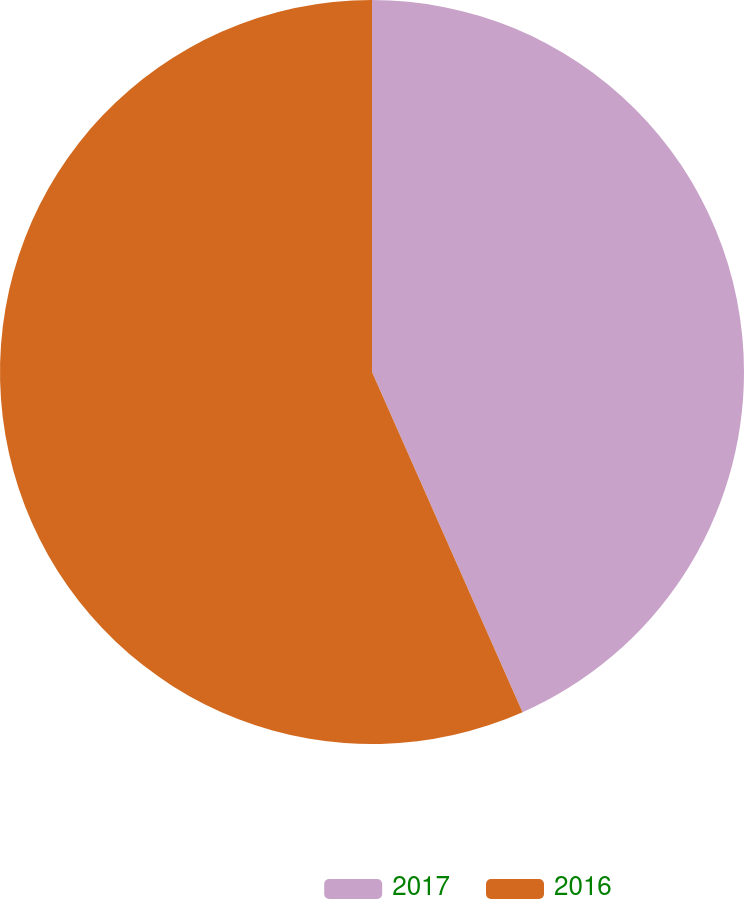Convert chart. <chart><loc_0><loc_0><loc_500><loc_500><pie_chart><fcel>2017<fcel>2016<nl><fcel>43.37%<fcel>56.63%<nl></chart> 